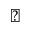<formula> <loc_0><loc_0><loc_500><loc_500>\vartriangle</formula> 